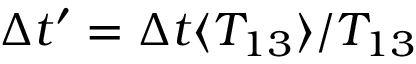<formula> <loc_0><loc_0><loc_500><loc_500>\Delta t ^ { \prime } = \Delta t \langle { T _ { 1 3 } } / T _ { 1 3 }</formula> 